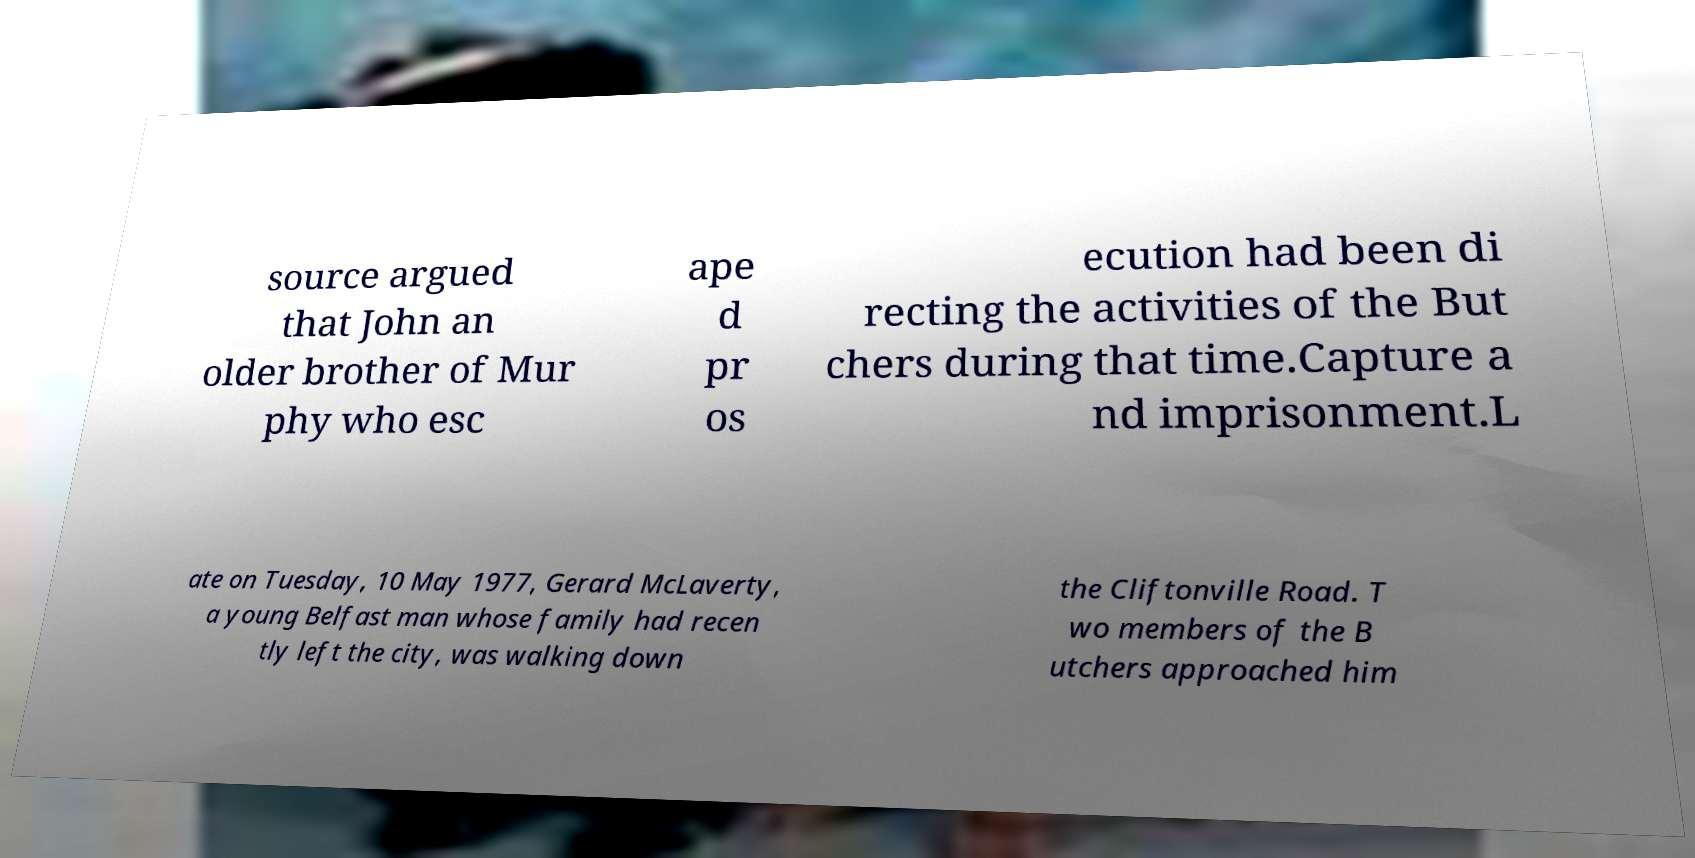Please identify and transcribe the text found in this image. source argued that John an older brother of Mur phy who esc ape d pr os ecution had been di recting the activities of the But chers during that time.Capture a nd imprisonment.L ate on Tuesday, 10 May 1977, Gerard McLaverty, a young Belfast man whose family had recen tly left the city, was walking down the Cliftonville Road. T wo members of the B utchers approached him 